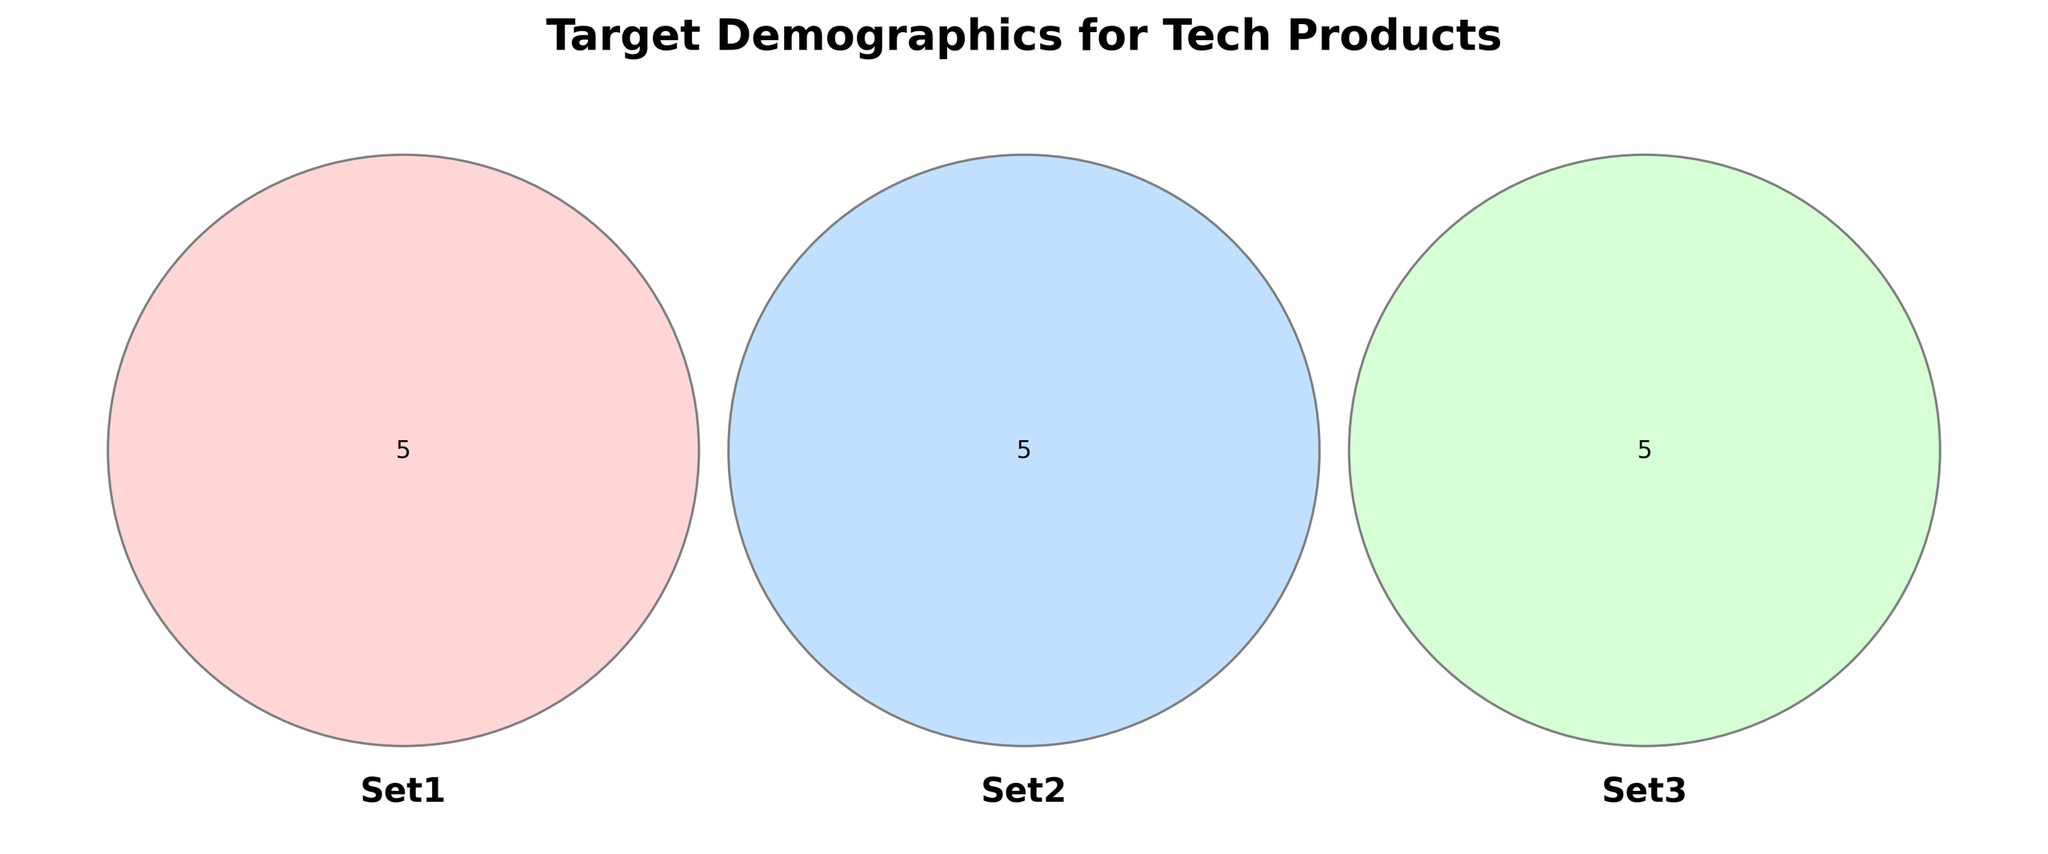what are the three sets shown in the diagram? The title and labels of the Venn Diagram indicate the three sets being compared.
Answer: Millennials, Gen Z, Tech Enthusiasts which demographic overlaps with both Millennials and Gen Z? In a Venn Diagram, the region where two sets intersect highlights common elements. Here, look for the area where Millennial and Gen Z circles overlap.
Answer: Students how many elements are exclusive to Gen Z? To find this, identify elements in the Gen Z circle that do not overlap with the other circles.
Answer: Suburban, Android Users which group is present in all three sets? Look at the intersection area where all three circles meet to find the shared group among all sets.
Answer: Social Media Users which target demographic belongs to both Millennials and Tech Enthusiasts but not Gen Z? Notice the overlapping region between the Millennial and Tech Enthusiast circles that excludes the Gen Z circle.
Answer: High Income, College Educated which set has the most exclusive elements? Compare the segments for each set that do not intersect with any other set to determine the one with the highest count.
Answer: Tech Enthusiasts is there any group that is common to Tech Enthusiasts and Gen Z but not Millennials? Look at the overlapping area between Tech Enthusiasts and Gen Z, excluding the Millennials circle.
Answer: Yes, Gamers 